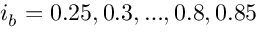<formula> <loc_0><loc_0><loc_500><loc_500>i _ { b } = 0 . 2 5 , 0 . 3 , , 0 . 8 , 0 . 8 5</formula> 